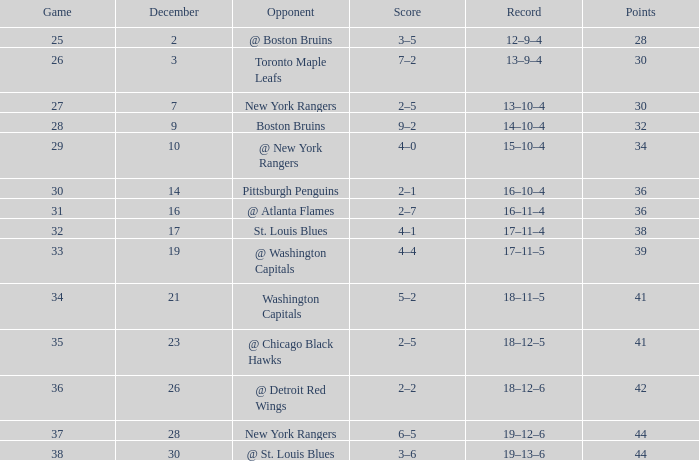Which result has a historical record of 18 victories, 11 defeats, and 5 ties? 5–2. 